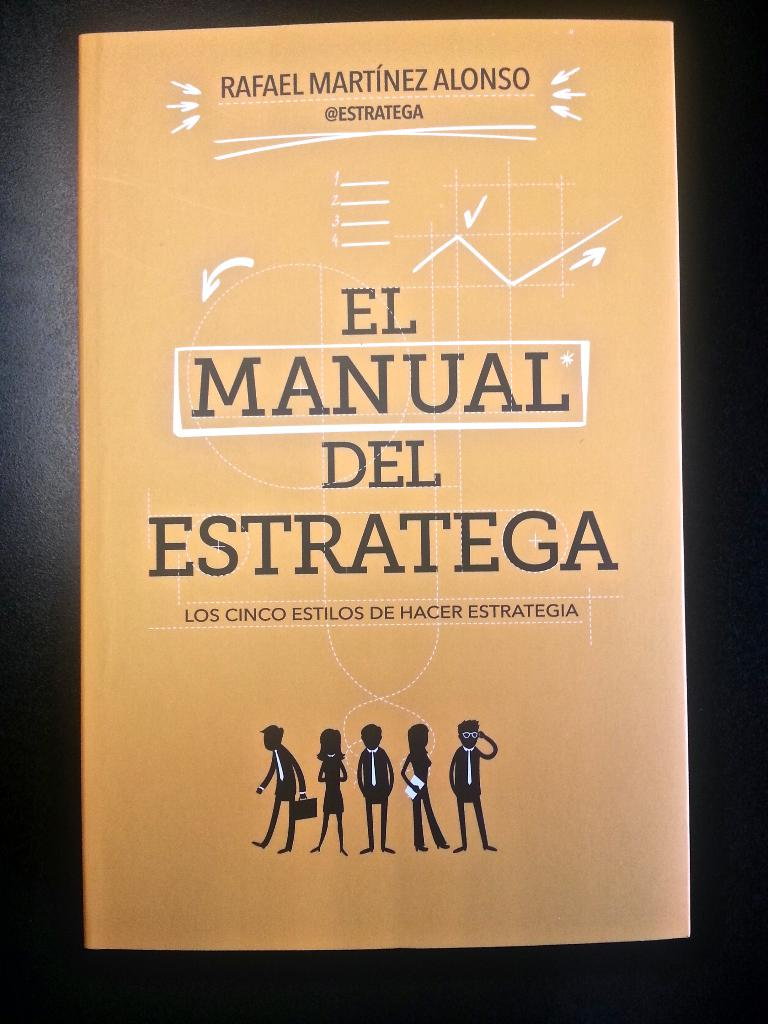What do the different styles of characters on the cover suggest about the contents of the book? The diverse silhouettes of the characters on the cover of 'El Manual del Estratega' suggest a comprehensive guide to various approaches in strategy-making. Each character's distinct appearance—from business casual to formal—reflects the diverse environments and contexts in which strategic thinking can be applied, emphasizing the book's utility for readers with different roles and in various sectors. This illustrative approach hints that the book may cover topics from foundational strategic principles to more nuanced and specialized tactics designed for specific professional scenarios. 